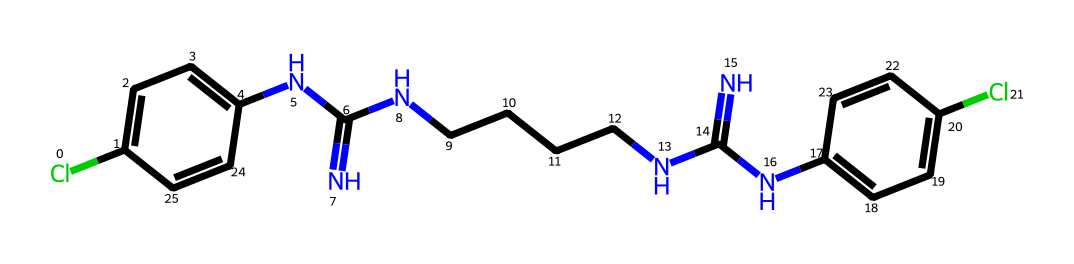What is the molecular formula of chlorhexidine? The molecular formula can be derived from the SMILES representation by identifying the number of each type of atom present, counting the carbon (C), hydrogen (H), chlorine (Cl), and nitrogen (N) atoms. There are 22 carbons, 30 hydrogens, 2 nitrogens, and 2 chlorines, resulting in the formula C22H30Cl2N4.
Answer: C22H30Cl2N4 How many rings are present in the chlorhexidine structure? By analyzing the SMILES representation, we can see that there are two aromatic rings indicated by the 'c' (for carbon in a ring) notation. Each 'c' represents a part of a benzene ring which is cyclic in nature. Thus, there are two rings in the structure.
Answer: 2 What is the impact of chlorine atoms in chlorhexidine? Chlorine atoms in the structure contribute to both the antiseptic properties and the degree of hydrophobicity and reactivity of the molecule. Their presence can enhance the antibacterial efficacy by disrupting cellular membranes.
Answer: Antiseptic properties How many nitrogen atoms are present in the chlorhexidine molecule? The SMILES string shows four nitrogen atoms as indicated by the letter 'N' throughout the structure. Counting each instance of 'N' reveals the presence of four nitrogen atoms total.
Answer: 4 Is chlorhexidine considered a flammable liquid? Chlorhexidine is not typically classified as a flammable liquid; instead, it has a higher boiling point and is usually categorized as non-flammable due to its chemical structure that does not allow for easy combustion.
Answer: No What functional groups are present in chlorhexidine? The chlorhexidine structure includes amine groups (due to the nitrogen atoms) inferred from the NC(=N) parts, and the aromatic rings imply the presence of phenolic hydroxyl groups as part of its molecular design.
Answer: Amine and aromatic groups What role does the long carbon chain play in the chlorhexidine structure? The long carbon chain enhances the lipid solubility of the compound. This feature allows chlorhexidine to better interact with the lipid membranes of microbial cells, improving its antiseptic activity.
Answer: Increases lipid solubility 